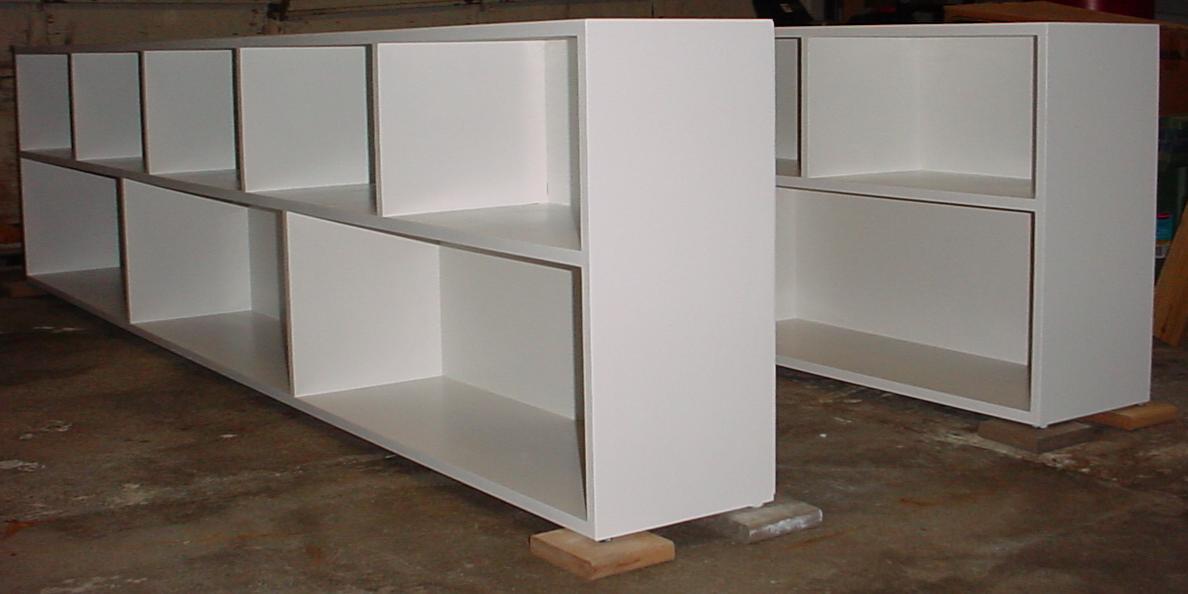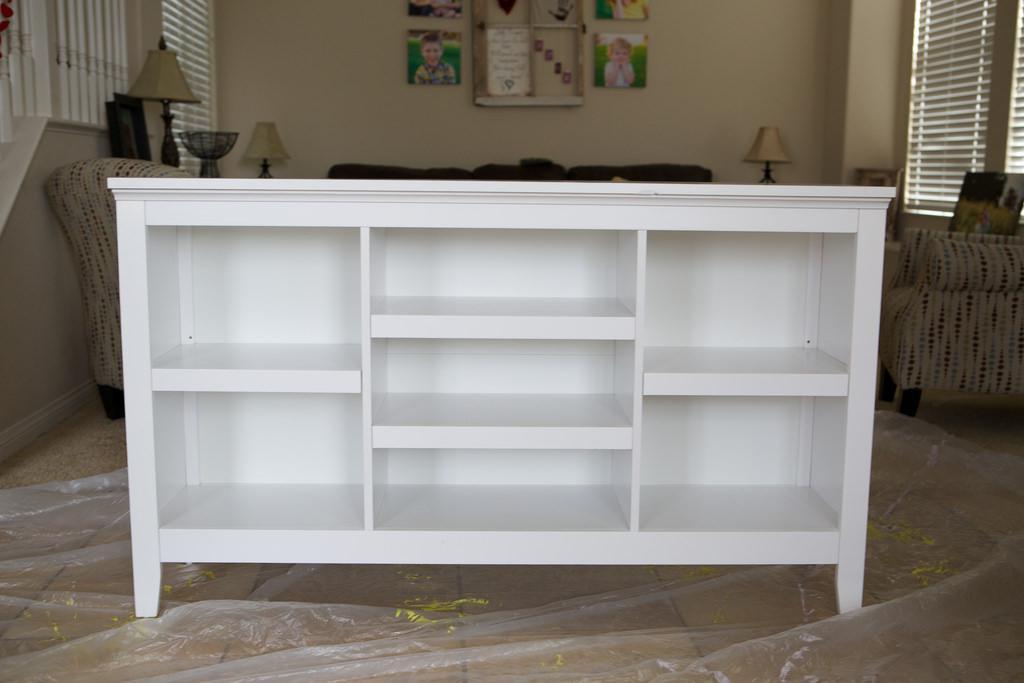The first image is the image on the left, the second image is the image on the right. Evaluate the accuracy of this statement regarding the images: "All of the bookshelves are empty.". Is it true? Answer yes or no. Yes. The first image is the image on the left, the second image is the image on the right. Considering the images on both sides, is "An image includes an empty white shelf unit with two layers of staggered compartments." valid? Answer yes or no. Yes. 